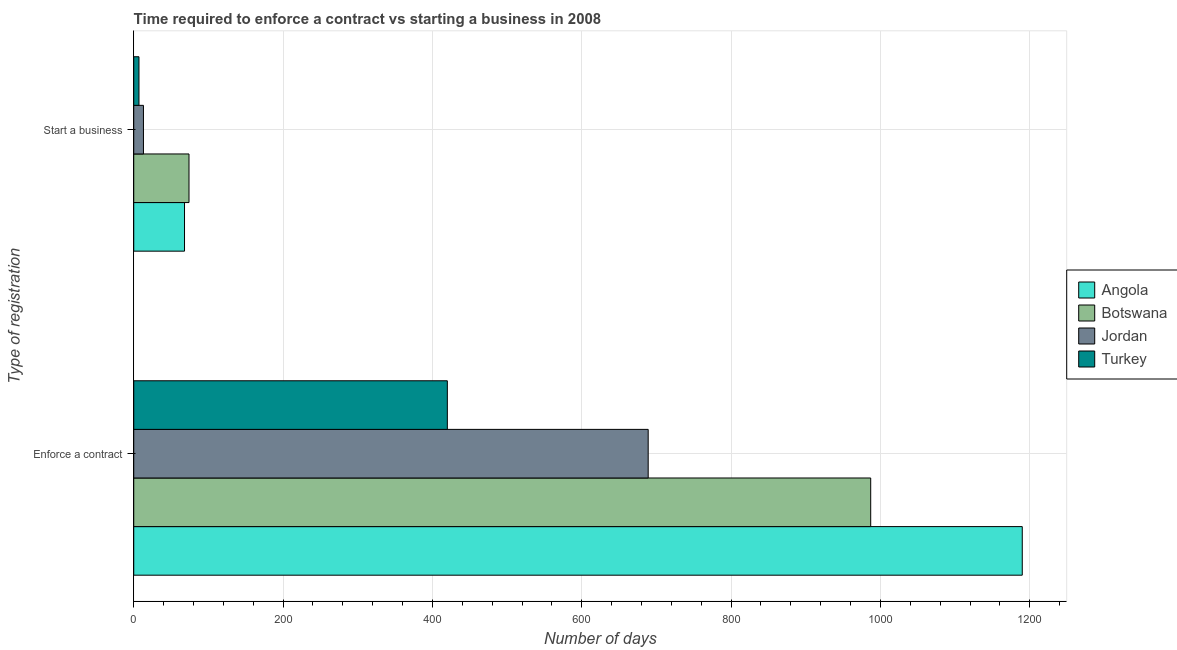How many different coloured bars are there?
Your response must be concise. 4. How many groups of bars are there?
Give a very brief answer. 2. How many bars are there on the 1st tick from the bottom?
Make the answer very short. 4. What is the label of the 1st group of bars from the top?
Provide a succinct answer. Start a business. What is the number of days to start a business in Botswana?
Keep it short and to the point. 74. Across all countries, what is the maximum number of days to enforece a contract?
Your response must be concise. 1190. Across all countries, what is the minimum number of days to enforece a contract?
Your answer should be compact. 420. In which country was the number of days to start a business maximum?
Give a very brief answer. Botswana. In which country was the number of days to start a business minimum?
Offer a very short reply. Turkey. What is the total number of days to start a business in the graph?
Provide a short and direct response. 162. What is the difference between the number of days to enforece a contract in Turkey and the number of days to start a business in Angola?
Offer a very short reply. 352. What is the average number of days to enforece a contract per country?
Provide a short and direct response. 821.5. What is the difference between the number of days to enforece a contract and number of days to start a business in Turkey?
Your answer should be very brief. 413. In how many countries, is the number of days to start a business greater than 1080 days?
Provide a short and direct response. 0. What is the ratio of the number of days to enforece a contract in Jordan to that in Angola?
Provide a short and direct response. 0.58. Is the number of days to start a business in Turkey less than that in Jordan?
Offer a very short reply. Yes. In how many countries, is the number of days to start a business greater than the average number of days to start a business taken over all countries?
Offer a very short reply. 2. What does the 4th bar from the top in Enforce a contract represents?
Keep it short and to the point. Angola. What does the 4th bar from the bottom in Start a business represents?
Offer a terse response. Turkey. How many countries are there in the graph?
Ensure brevity in your answer.  4. What is the difference between two consecutive major ticks on the X-axis?
Ensure brevity in your answer.  200. Are the values on the major ticks of X-axis written in scientific E-notation?
Ensure brevity in your answer.  No. What is the title of the graph?
Provide a short and direct response. Time required to enforce a contract vs starting a business in 2008. What is the label or title of the X-axis?
Your response must be concise. Number of days. What is the label or title of the Y-axis?
Your response must be concise. Type of registration. What is the Number of days of Angola in Enforce a contract?
Keep it short and to the point. 1190. What is the Number of days in Botswana in Enforce a contract?
Make the answer very short. 987. What is the Number of days of Jordan in Enforce a contract?
Offer a terse response. 689. What is the Number of days in Turkey in Enforce a contract?
Your answer should be compact. 420. What is the Number of days in Angola in Start a business?
Offer a very short reply. 68. What is the Number of days in Turkey in Start a business?
Provide a short and direct response. 7. Across all Type of registration, what is the maximum Number of days in Angola?
Offer a very short reply. 1190. Across all Type of registration, what is the maximum Number of days of Botswana?
Keep it short and to the point. 987. Across all Type of registration, what is the maximum Number of days in Jordan?
Ensure brevity in your answer.  689. Across all Type of registration, what is the maximum Number of days in Turkey?
Offer a terse response. 420. Across all Type of registration, what is the minimum Number of days of Botswana?
Make the answer very short. 74. Across all Type of registration, what is the minimum Number of days of Turkey?
Offer a very short reply. 7. What is the total Number of days of Angola in the graph?
Your response must be concise. 1258. What is the total Number of days of Botswana in the graph?
Your answer should be compact. 1061. What is the total Number of days in Jordan in the graph?
Offer a very short reply. 702. What is the total Number of days in Turkey in the graph?
Offer a terse response. 427. What is the difference between the Number of days in Angola in Enforce a contract and that in Start a business?
Provide a short and direct response. 1122. What is the difference between the Number of days of Botswana in Enforce a contract and that in Start a business?
Offer a very short reply. 913. What is the difference between the Number of days in Jordan in Enforce a contract and that in Start a business?
Make the answer very short. 676. What is the difference between the Number of days of Turkey in Enforce a contract and that in Start a business?
Keep it short and to the point. 413. What is the difference between the Number of days of Angola in Enforce a contract and the Number of days of Botswana in Start a business?
Ensure brevity in your answer.  1116. What is the difference between the Number of days of Angola in Enforce a contract and the Number of days of Jordan in Start a business?
Your answer should be very brief. 1177. What is the difference between the Number of days of Angola in Enforce a contract and the Number of days of Turkey in Start a business?
Ensure brevity in your answer.  1183. What is the difference between the Number of days of Botswana in Enforce a contract and the Number of days of Jordan in Start a business?
Keep it short and to the point. 974. What is the difference between the Number of days in Botswana in Enforce a contract and the Number of days in Turkey in Start a business?
Keep it short and to the point. 980. What is the difference between the Number of days of Jordan in Enforce a contract and the Number of days of Turkey in Start a business?
Your answer should be very brief. 682. What is the average Number of days of Angola per Type of registration?
Offer a terse response. 629. What is the average Number of days of Botswana per Type of registration?
Provide a short and direct response. 530.5. What is the average Number of days in Jordan per Type of registration?
Make the answer very short. 351. What is the average Number of days of Turkey per Type of registration?
Your answer should be very brief. 213.5. What is the difference between the Number of days in Angola and Number of days in Botswana in Enforce a contract?
Keep it short and to the point. 203. What is the difference between the Number of days in Angola and Number of days in Jordan in Enforce a contract?
Make the answer very short. 501. What is the difference between the Number of days of Angola and Number of days of Turkey in Enforce a contract?
Offer a very short reply. 770. What is the difference between the Number of days of Botswana and Number of days of Jordan in Enforce a contract?
Keep it short and to the point. 298. What is the difference between the Number of days of Botswana and Number of days of Turkey in Enforce a contract?
Your response must be concise. 567. What is the difference between the Number of days of Jordan and Number of days of Turkey in Enforce a contract?
Ensure brevity in your answer.  269. What is the difference between the Number of days in Angola and Number of days in Botswana in Start a business?
Make the answer very short. -6. What is the difference between the Number of days of Angola and Number of days of Jordan in Start a business?
Provide a short and direct response. 55. What is the difference between the Number of days of Botswana and Number of days of Turkey in Start a business?
Give a very brief answer. 67. What is the difference between the Number of days in Jordan and Number of days in Turkey in Start a business?
Provide a succinct answer. 6. What is the ratio of the Number of days of Botswana in Enforce a contract to that in Start a business?
Ensure brevity in your answer.  13.34. What is the ratio of the Number of days in Turkey in Enforce a contract to that in Start a business?
Offer a very short reply. 60. What is the difference between the highest and the second highest Number of days in Angola?
Make the answer very short. 1122. What is the difference between the highest and the second highest Number of days of Botswana?
Offer a terse response. 913. What is the difference between the highest and the second highest Number of days of Jordan?
Keep it short and to the point. 676. What is the difference between the highest and the second highest Number of days of Turkey?
Provide a short and direct response. 413. What is the difference between the highest and the lowest Number of days in Angola?
Provide a succinct answer. 1122. What is the difference between the highest and the lowest Number of days of Botswana?
Offer a terse response. 913. What is the difference between the highest and the lowest Number of days in Jordan?
Your answer should be compact. 676. What is the difference between the highest and the lowest Number of days of Turkey?
Keep it short and to the point. 413. 